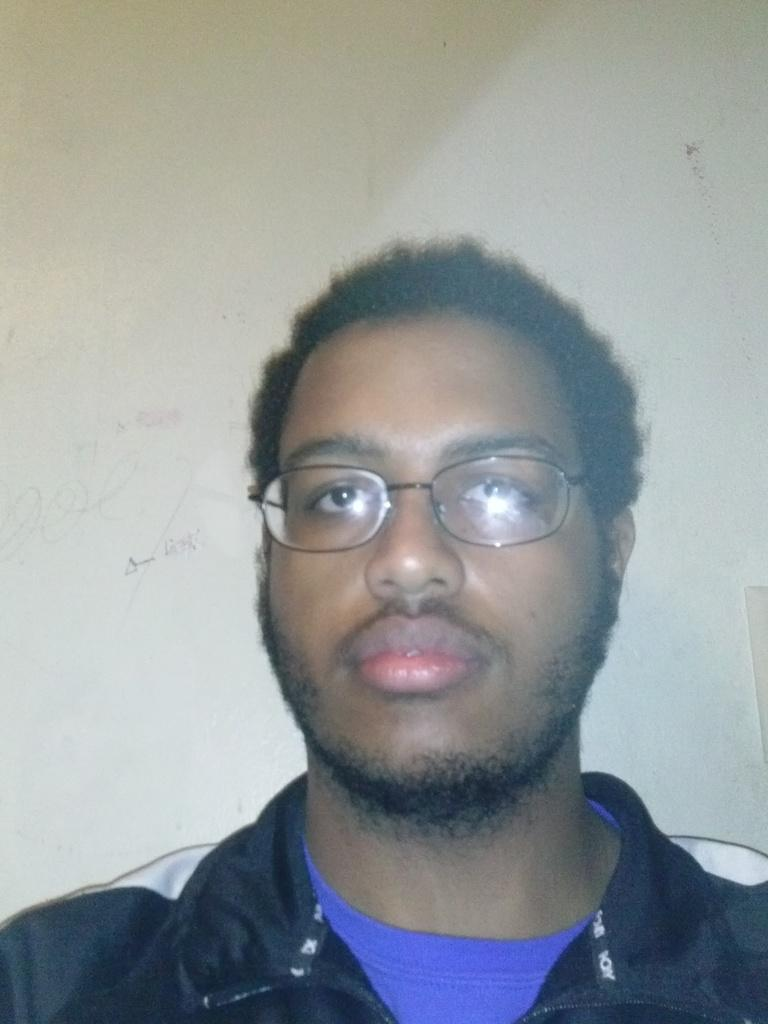Who or what is present in the image? There is a person in the image. What can be seen in the background of the image? There is a wall in the image. What type of table is being observed in the image? There is no table present in the image; it only features a person and a wall. 